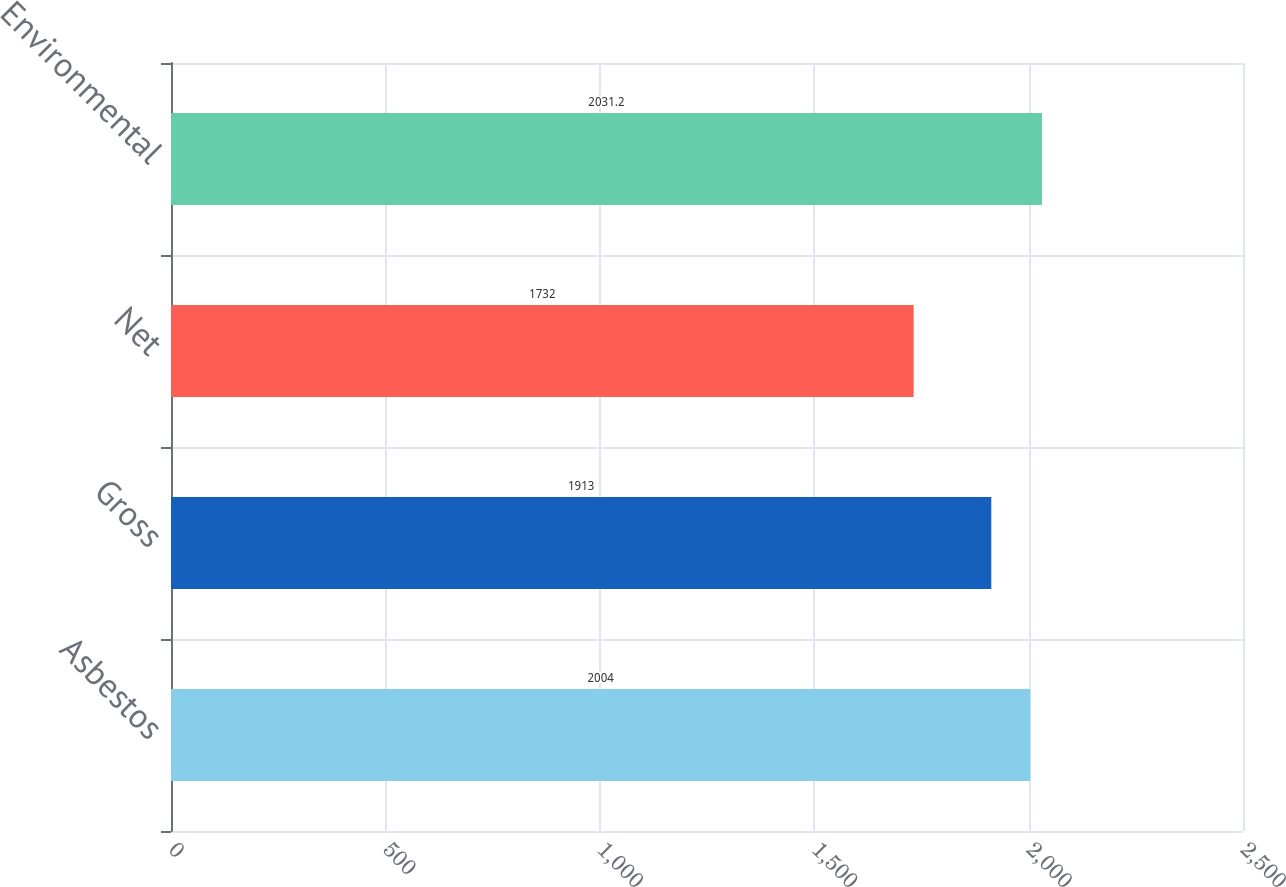<chart> <loc_0><loc_0><loc_500><loc_500><bar_chart><fcel>Asbestos<fcel>Gross<fcel>Net<fcel>Environmental<nl><fcel>2004<fcel>1913<fcel>1732<fcel>2031.2<nl></chart> 